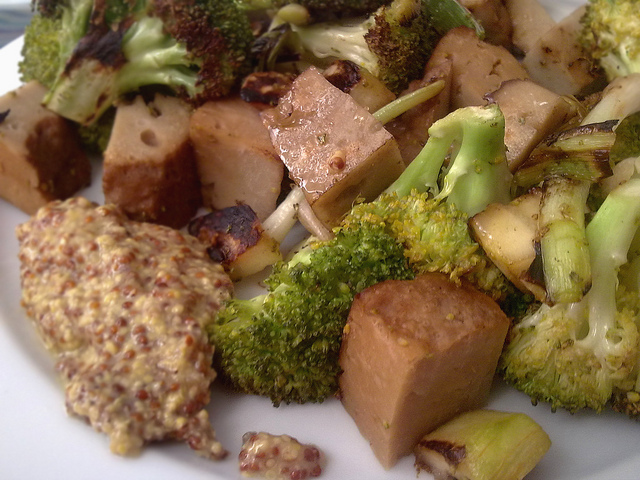How many plates are there? The image does not show any traditional dining plates; instead, it features a meal directly served on a plate with tofu, broccoli, and additional vegetables. It seems like this question might be a misunderstanding, as there are no visible plates in the traditional sense. 